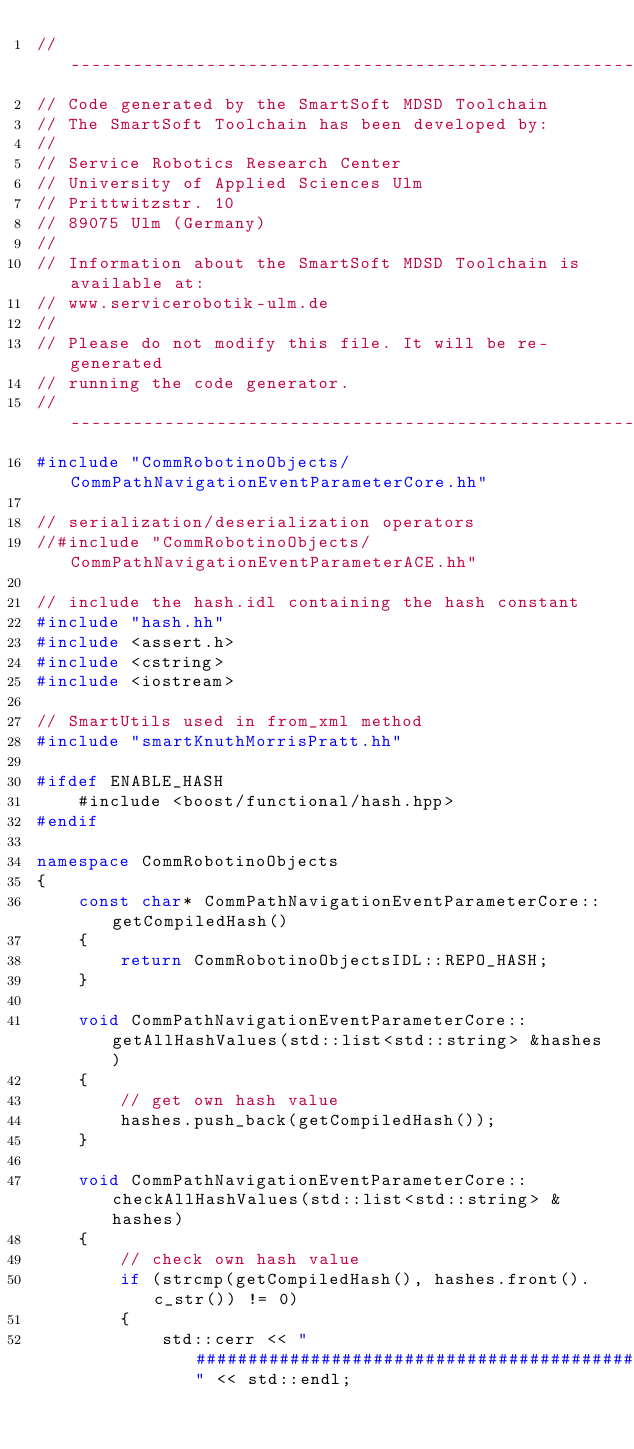<code> <loc_0><loc_0><loc_500><loc_500><_C++_>//--------------------------------------------------------------------------
// Code generated by the SmartSoft MDSD Toolchain
// The SmartSoft Toolchain has been developed by:
//  
// Service Robotics Research Center
// University of Applied Sciences Ulm
// Prittwitzstr. 10
// 89075 Ulm (Germany)
//
// Information about the SmartSoft MDSD Toolchain is available at:
// www.servicerobotik-ulm.de
//
// Please do not modify this file. It will be re-generated
// running the code generator.
//--------------------------------------------------------------------------
#include "CommRobotinoObjects/CommPathNavigationEventParameterCore.hh"

// serialization/deserialization operators
//#include "CommRobotinoObjects/CommPathNavigationEventParameterACE.hh"

// include the hash.idl containing the hash constant
#include "hash.hh"
#include <assert.h>
#include <cstring>
#include <iostream>

// SmartUtils used in from_xml method
#include "smartKnuthMorrisPratt.hh"

#ifdef ENABLE_HASH
	#include <boost/functional/hash.hpp>
#endif

namespace CommRobotinoObjects 
{
	const char* CommPathNavigationEventParameterCore::getCompiledHash()
	{
		return CommRobotinoObjectsIDL::REPO_HASH;
	}
	
	void CommPathNavigationEventParameterCore::getAllHashValues(std::list<std::string> &hashes)
	{
		// get own hash value
		hashes.push_back(getCompiledHash());
	}
	
	void CommPathNavigationEventParameterCore::checkAllHashValues(std::list<std::string> &hashes)
	{
		// check own hash value
		if (strcmp(getCompiledHash(), hashes.front().c_str()) != 0)
		{
			std::cerr << "###################################################" << std::endl;</code> 